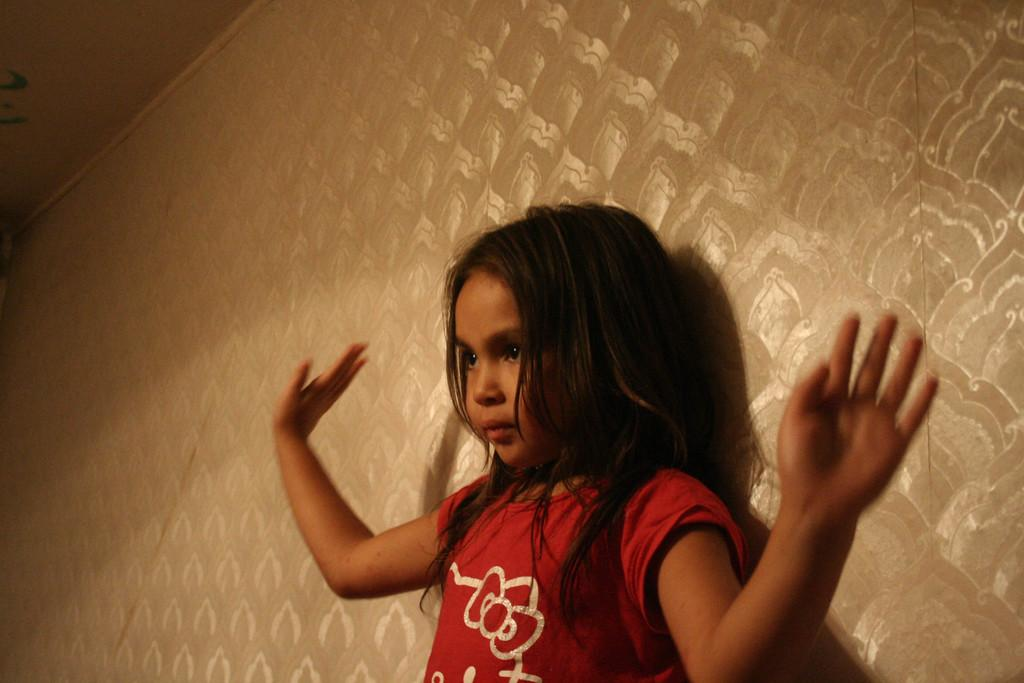Where was the image taken? The image was taken indoors. What can be seen in the background of the image? There is a wall in the background of the image. Who is the main subject in the image? There is a girl in the middle of the image. What is above the girl in the image? There is a ceiling at the top of the image. What type of spade is the girl using in the image? There is no spade present in the image. Can you tell me how many copies of the girl are in the image? There is only one girl in the image, so there are no copies. 